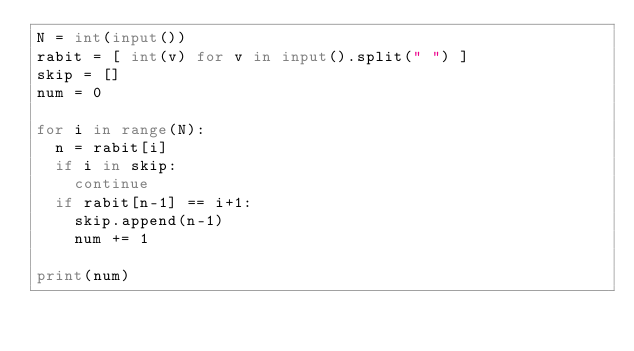<code> <loc_0><loc_0><loc_500><loc_500><_Python_>N = int(input())
rabit = [ int(v) for v in input().split(" ") ]
skip = []
num = 0

for i in range(N):
  n = rabit[i]
  if i in skip:
    continue
  if rabit[n-1] == i+1:
    skip.append(n-1)
    num += 1

print(num)</code> 